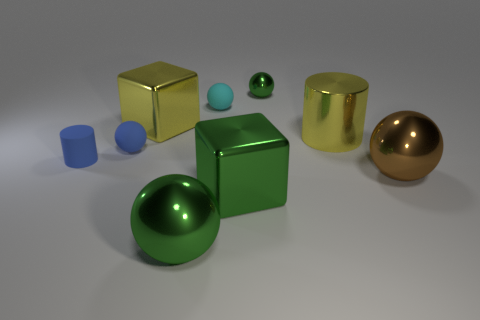What number of other objects are there of the same size as the yellow cylinder?
Give a very brief answer. 4. What is the material of the sphere to the left of the green metallic sphere that is in front of the cylinder that is to the left of the small cyan object?
Make the answer very short. Rubber. Do the cyan matte thing and the green thing that is behind the big green block have the same size?
Your answer should be very brief. Yes. How big is the metal object that is both to the right of the small cyan rubber object and behind the yellow cylinder?
Make the answer very short. Small. Are there any things of the same color as the big cylinder?
Give a very brief answer. Yes. There is a big object to the left of the metal ball on the left side of the tiny metallic ball; what color is it?
Your response must be concise. Yellow. Are there fewer yellow objects to the left of the big green shiny cube than metallic things to the right of the small cyan sphere?
Provide a short and direct response. Yes. Is the shiny cylinder the same size as the blue ball?
Make the answer very short. No. There is a big thing that is both to the left of the big green cube and in front of the big brown metal sphere; what is its shape?
Offer a terse response. Sphere. How many large yellow cylinders are the same material as the big green ball?
Provide a succinct answer. 1. 